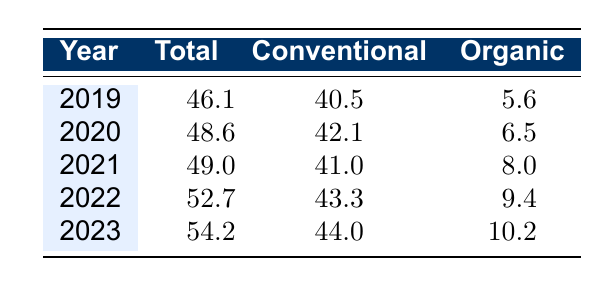What was the total milk production volume in 2022? The total milk production volume for 2022 is noted in the table under the "Total" column, which shows 52.7 million liters for that year.
Answer: 52.7 million liters How much more milk was produced from conventional sources than organic sources in 2021? For 2021, the conventional milk production volume is 41.0 million liters and the organic volume is 8.0 million liters. The difference is 41.0 - 8.0 = 33.0 million liters.
Answer: 33.0 million liters Did the total milk production volume increase every year from 2019 to 2023? By reviewing the total values for each year in the table, it shows that the total production increased from 46.1 in 2019 to 54.2 in 2023. Hence, it increased each year without exception.
Answer: Yes What was the average yearly production volume from organic sources over the 5 years? The organic production volumes for the years are 5.6, 6.5, 8.0, 9.4, and 10.2 million liters. To find the average, sum these values: 5.6 + 6.5 + 8.0 + 9.4 + 10.2 = 39.7 million liters, then divide by 5: 39.7 / 5 = 7.94 million liters.
Answer: 7.94 million liters In which year was the increase in organic milk production the highest compared to the previous year? By examining the values, the organic production increased from 8.0 million liters in 2021 to 9.4 million liters in 2022, which is an increase of 1.4 million liters. Other increases were smaller: 0.9 from 2019 to 2020, 1.5 from 2020 to 2021, and 0.8 from 2022 to 2023. Thus, the highest increase occurred from 2021 to 2022.
Answer: 2022 What is the percentage increase in conventional milk production from 2019 to 2023? The conventional production in 2019 was 40.5 million liters and in 2023 it was 44.0 million liters. The increase is 44.0 - 40.5 = 3.5 million liters. To find the percentage increase, use the formula (increase/original)*100, which gives (3.5/40.5)*100 ≈ 8.64%.
Answer: Approximately 8.64% 